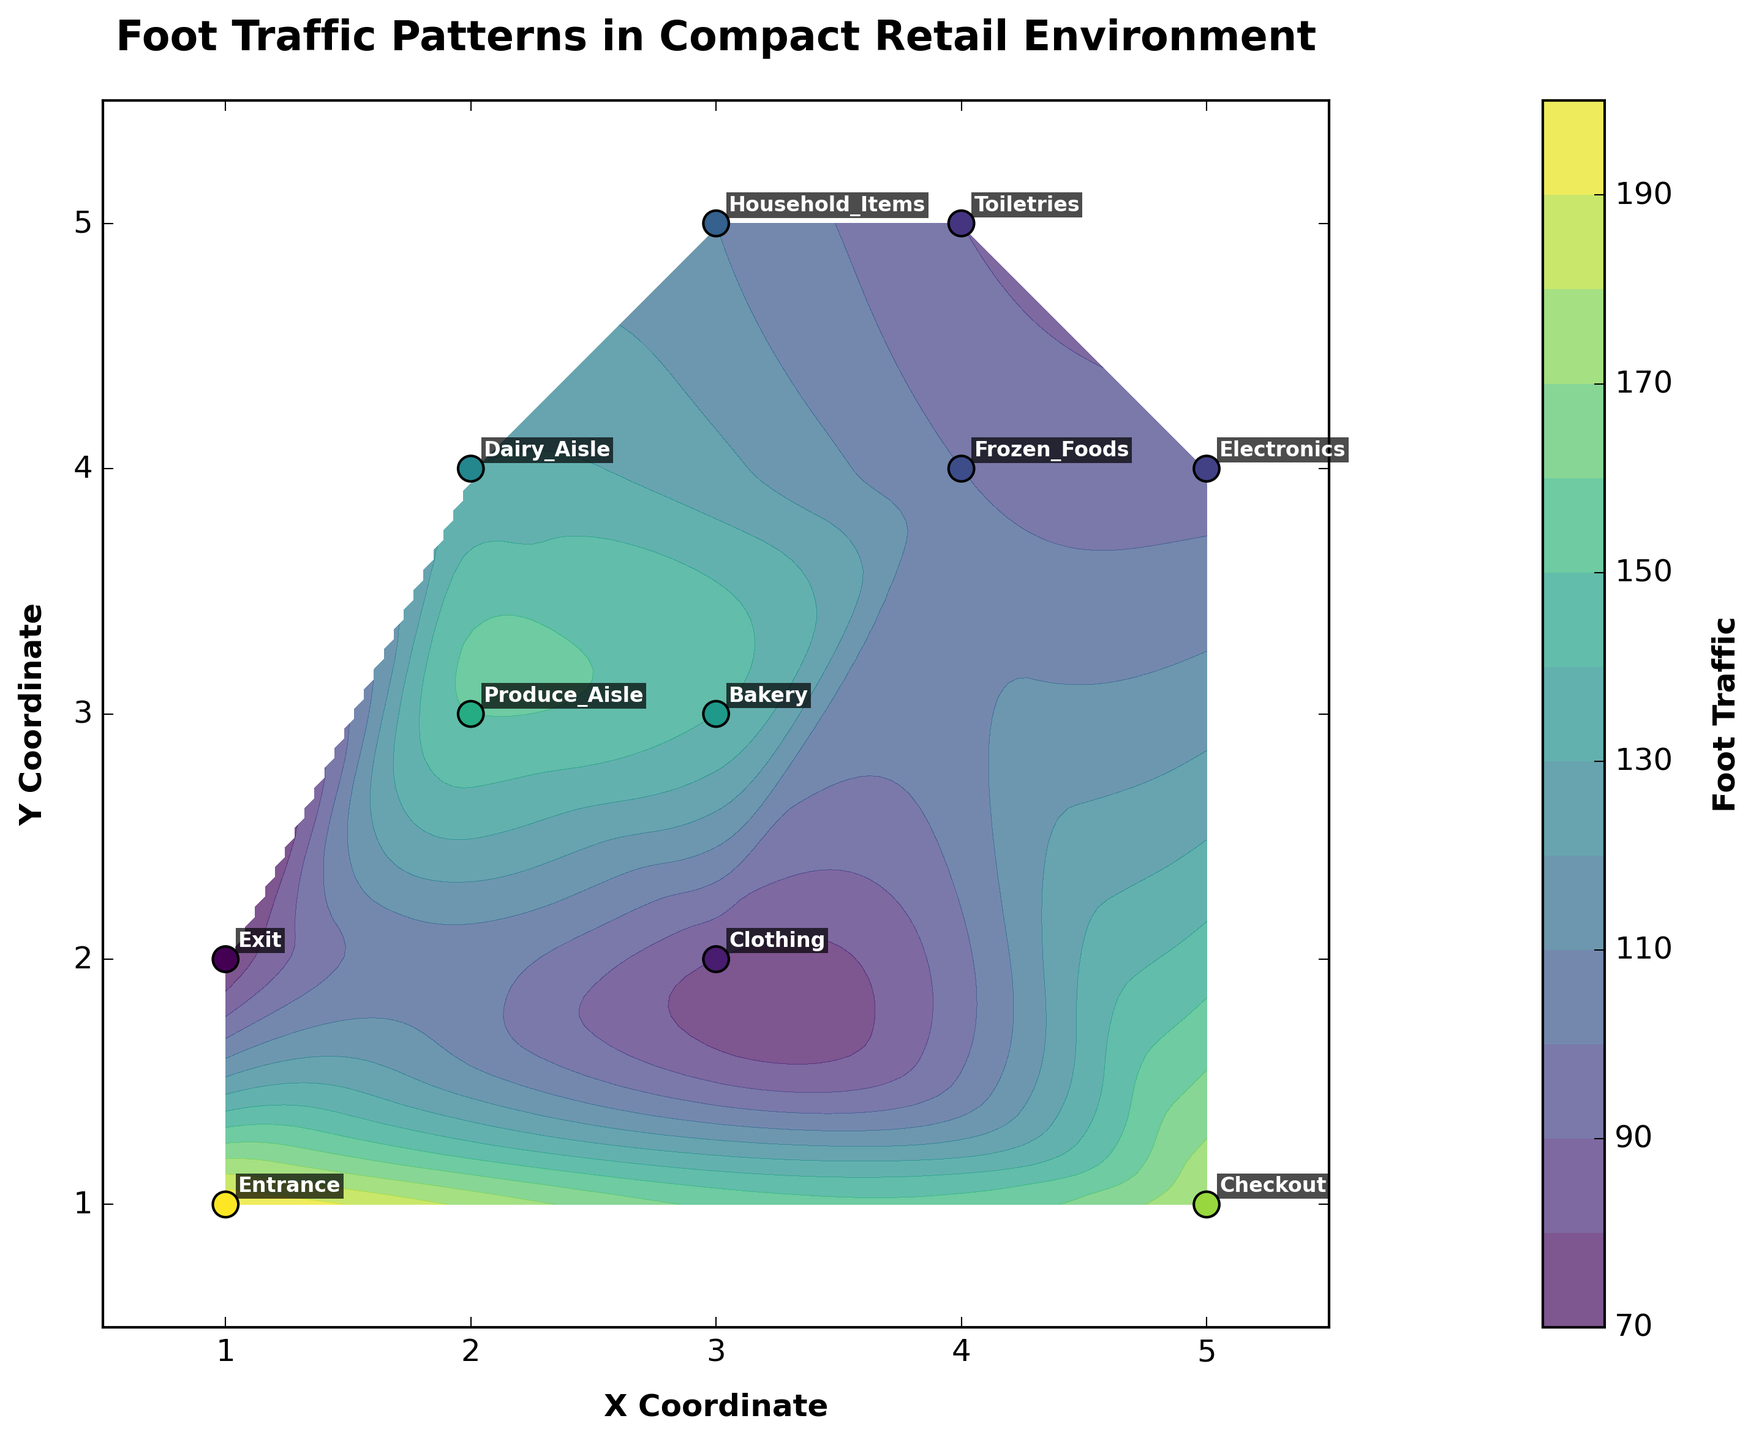what is the highest foot traffic section displayed on the plot? The hottest shade on the contour plot and the largest scatter point both identify that section. In this plot, the entrance has the highest foot traffic value of 200, confirmed by visual inspection.
Answer: Entrance What is the range of the X coordinate displayed in the title? The axis label on the plot states that the X coordinate spans from 0.5 to 5.5. This range is evident on the axis labels.
Answer: 0.5 to 5.5 What store sections are close to each other in terms of foot traffic values? By comparing the scatter points and their corresponding labels, we observe that the Produce Aisle (150), Dairy Aisle (130), and Bakery (140) are visually clustered closer together in terms of color and numeric foot traffic values.
Answer: Produce Aisle, Dairy Aisle, Bakery Which section has the lowest foot traffic, and what is its value? By identifying the smallest and least saturated scatter point, we find that Clothing has the lowest foot traffic value, 80.
Answer: Clothing, 80 What pattern can be observed for sections with higher foot traffic? The higher foot traffic values are seen mostly around the periphery of the plot, with the scatter points for Entrance (200), Checkout (180), and Bakery (140) showing higher foot traffic. Examining their locations gives an understanding of how customer movement flows.
Answer: Peripheral sections How do the foot traffic values of Bakery and Frozen Foods compare? The Bakery section shows a value of 140, whereas Frozen Foods displays 100. Bakery has higher foot traffic than Frozen Foods by 40.
Answer: Bakery is higher by 40 Are there any sections with similar scatter point colors but differing significantly in foot traffic values? Visually, Toilettries and Household Items have somewhat similar shades. However, Household Items have a value of 110 while Toilettries have 90—a 20-point difference.
Answer: Toilettries and Household Items What area of the plot appears to be less frequented by foot traffic overall? The upper mid-section of the plot, including sections like Toiletries (90), Electronics (95), and Frozen Foods (100), represent low foot traffic.
Answer: upper-mid section 